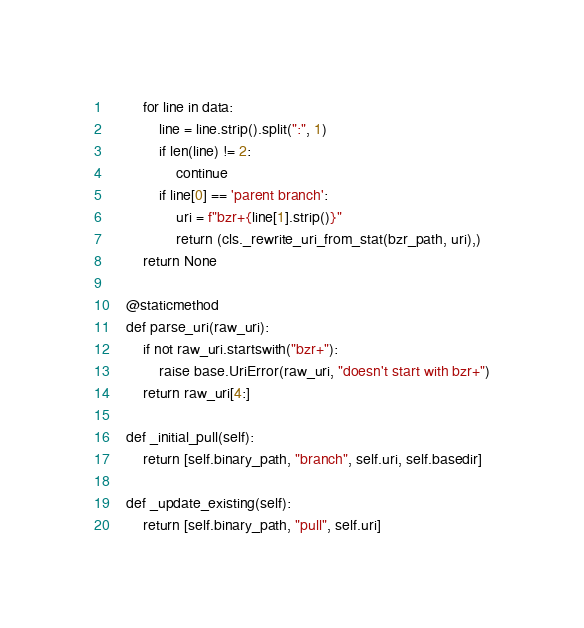<code> <loc_0><loc_0><loc_500><loc_500><_Python_>        for line in data:
            line = line.strip().split(":", 1)
            if len(line) != 2:
                continue
            if line[0] == 'parent branch':
                uri = f"bzr+{line[1].strip()}"
                return (cls._rewrite_uri_from_stat(bzr_path, uri),)
        return None

    @staticmethod
    def parse_uri(raw_uri):
        if not raw_uri.startswith("bzr+"):
            raise base.UriError(raw_uri, "doesn't start with bzr+")
        return raw_uri[4:]

    def _initial_pull(self):
        return [self.binary_path, "branch", self.uri, self.basedir]

    def _update_existing(self):
        return [self.binary_path, "pull", self.uri]
</code> 